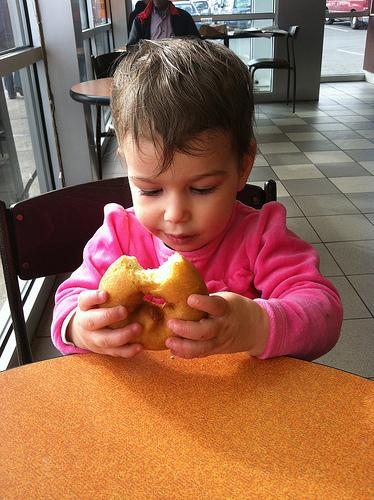State what the central figure is occupied with in the image. A child in pink is delightfully consuming a doughnut that has a bite taken out of it. Explain the main character and their chief pursuit in the photo. A girl wearing a pink outfit, with short brown hair, is happily eating a doughnut that has a bite in it. Identify the main person in the picture and describe the foremost activity being performed. A toddler, clad in a pink shirt, is engrossed in eating a doughnut with a portion eaten away. Portray the main individual and the central event taking place in the photograph. A young girl, clad in a pink shirt, is enjoying her doughnut, which is missing a bite, while sitting at a table. Elaborate on the chief character and their action within the photograph. A little girl with short brown hair, dressed in a pink sweater, is munching on a doughnut, which has a bite missing. Mention the primary focus of the image and the action taking place. A young girl wearing a pink shirt is eating a doughnut with a bite missing while sitting at an orange table. Point out the key figure in the image and summarize their principal action. A young child, donning a pink top, is devouring a partially eaten doughnut. Highlight the significant subject in the image and detail their crucial engagement. A small girl in a pink attire is relishing her doughnut, which has a bite mark, while seated at a table. Outline the central person and their primary activity in the image. A little girl dressed in pink, with open eyes, is feasting on a doughnut that has a small piece missing. Briefly describe the central individual and their main activity in the picture. A little girl in a pink long sleeve shirt enjoys eating her light brown doughnut at a table. 